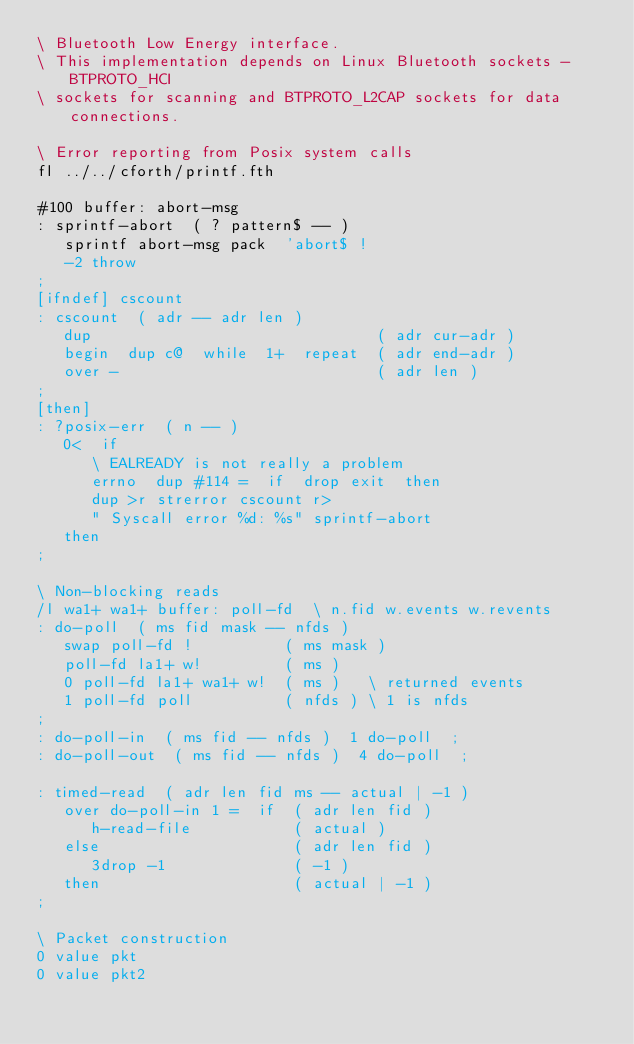<code> <loc_0><loc_0><loc_500><loc_500><_Forth_>\ Bluetooth Low Energy interface.
\ This implementation depends on Linux Bluetooth sockets - BTPROTO_HCI
\ sockets for scanning and BTPROTO_L2CAP sockets for data connections.

\ Error reporting from Posix system calls
fl ../../cforth/printf.fth

#100 buffer: abort-msg
: sprintf-abort  ( ? pattern$ -- )
   sprintf abort-msg pack  'abort$ !
   -2 throw
;
[ifndef] cscount
: cscount  ( adr -- adr len )
   dup                               ( adr cur-adr )
   begin  dup c@  while  1+  repeat  ( adr end-adr )
   over -                            ( adr len )
;
[then]
: ?posix-err  ( n -- )
   0<  if
      \ EALREADY is not really a problem
      errno  dup #114 =  if  drop exit  then
      dup >r strerror cscount r>
      " Syscall error %d: %s" sprintf-abort
   then
;

\ Non-blocking reads
/l wa1+ wa1+ buffer: poll-fd  \ n.fid w.events w.revents
: do-poll  ( ms fid mask -- nfds )
   swap poll-fd !          ( ms mask )
   poll-fd la1+ w!         ( ms )
   0 poll-fd la1+ wa1+ w!  ( ms )   \ returned events
   1 poll-fd poll          ( nfds ) \ 1 is nfds
;
: do-poll-in  ( ms fid -- nfds )  1 do-poll  ;
: do-poll-out  ( ms fid -- nfds )  4 do-poll  ;

: timed-read  ( adr len fid ms -- actual | -1 )
   over do-poll-in 1 =  if  ( adr len fid )
      h-read-file           ( actual )
   else                     ( adr len fid )
      3drop -1              ( -1 )
   then                     ( actual | -1 )
;

\ Packet construction
0 value pkt
0 value pkt2</code> 